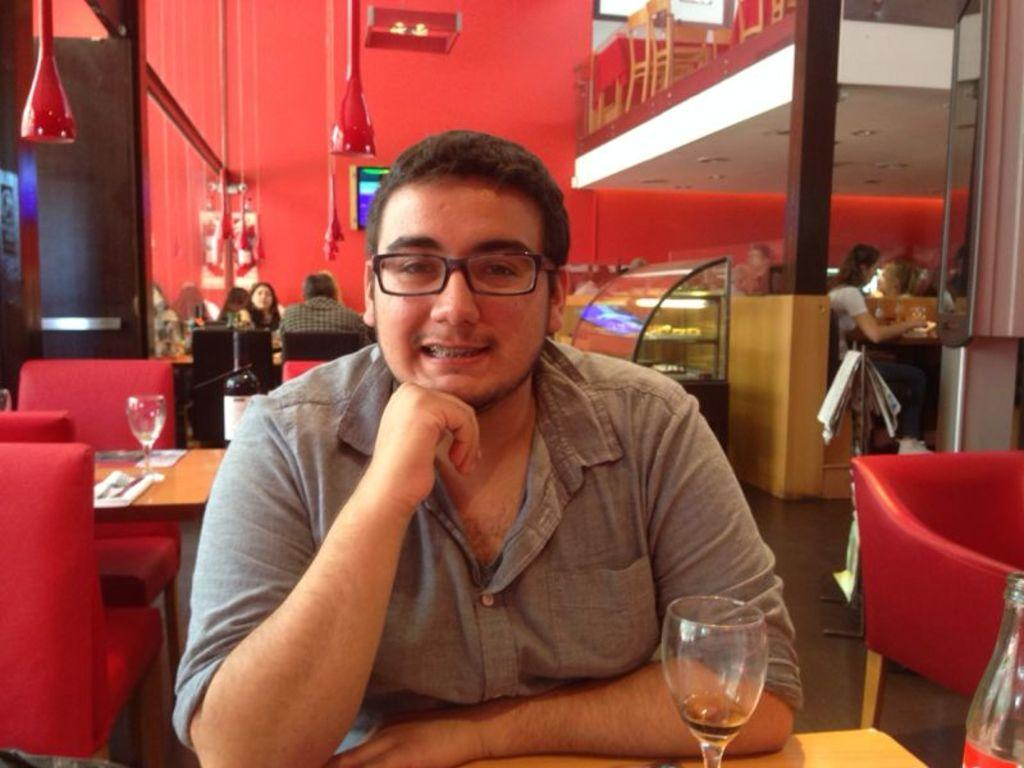What is the person in the image doing? There is a person sitting on a chair in the image. What can be seen on the table in the image? There is a wine glass and a wine bottle on the table in the image. Are there any other people in the image? Yes, there are other people sitting on chairs in the background of the image. Can you see any soup in the image? There is no soup present in the image. 